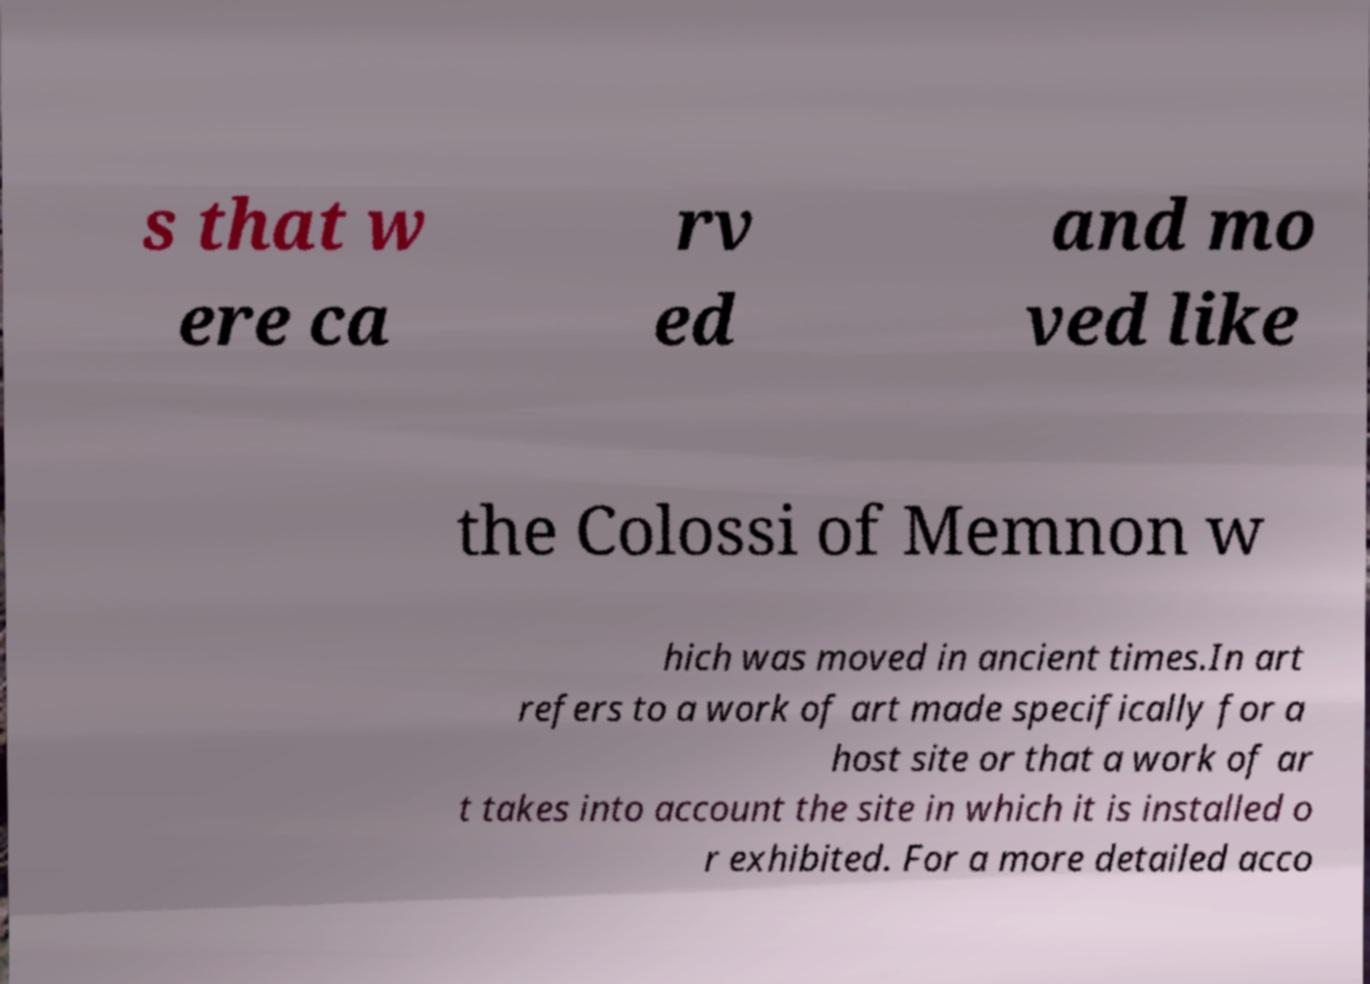Could you assist in decoding the text presented in this image and type it out clearly? s that w ere ca rv ed and mo ved like the Colossi of Memnon w hich was moved in ancient times.In art refers to a work of art made specifically for a host site or that a work of ar t takes into account the site in which it is installed o r exhibited. For a more detailed acco 